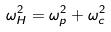<formula> <loc_0><loc_0><loc_500><loc_500>\omega _ { H } ^ { 2 } = \omega _ { p } ^ { 2 } + \omega _ { c } ^ { 2 }</formula> 